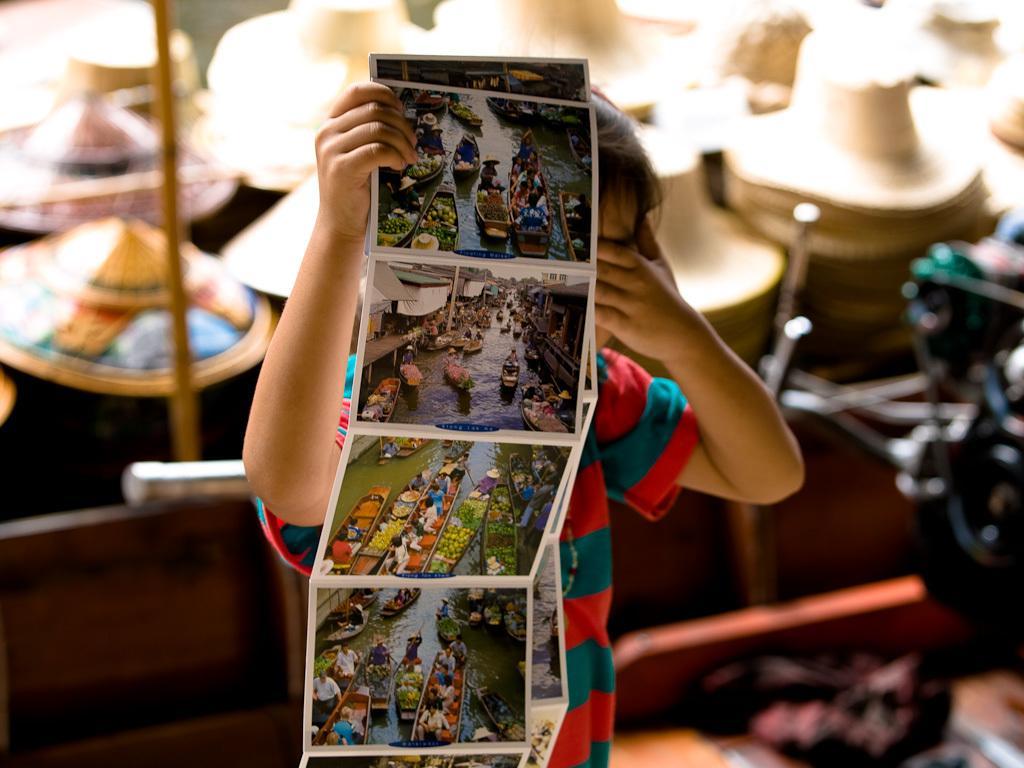In one or two sentences, can you explain what this image depicts? In this image, we can see a kid is holding some photographs. Background there is a blur view. Here we can see so many hats, pole, some objects. 